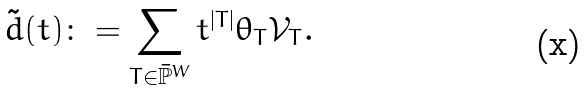<formula> <loc_0><loc_0><loc_500><loc_500>\tilde { d } ( t ) \colon = \sum _ { T \in \bar { \mathbb { P } } ^ { W } } t ^ { | T | } \theta _ { T } { \mathcal { V } _ { T } } .</formula> 